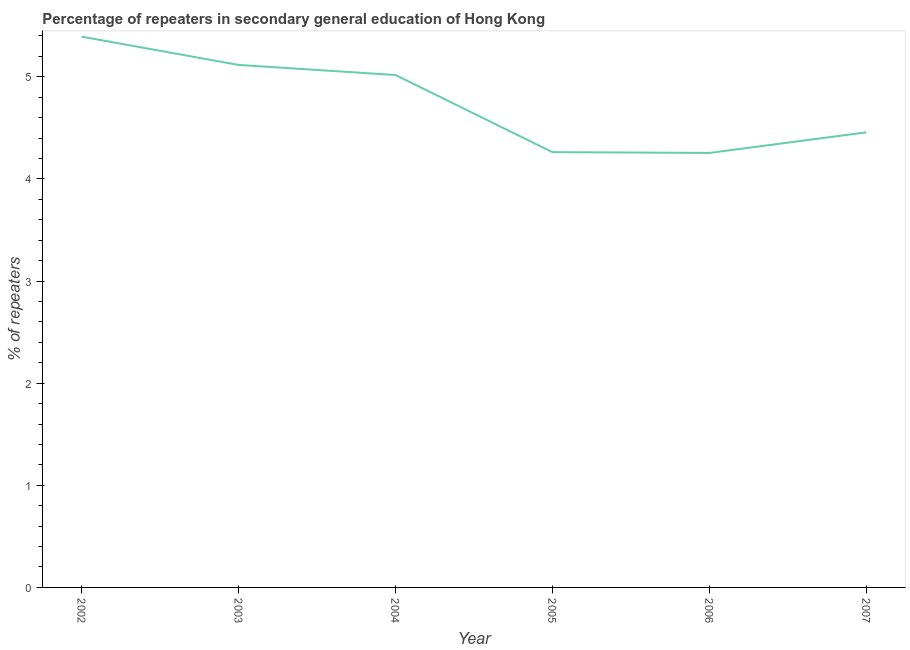What is the percentage of repeaters in 2007?
Provide a short and direct response. 4.46. Across all years, what is the maximum percentage of repeaters?
Your response must be concise. 5.39. Across all years, what is the minimum percentage of repeaters?
Give a very brief answer. 4.25. In which year was the percentage of repeaters maximum?
Your response must be concise. 2002. In which year was the percentage of repeaters minimum?
Offer a terse response. 2006. What is the sum of the percentage of repeaters?
Your response must be concise. 28.5. What is the difference between the percentage of repeaters in 2003 and 2004?
Ensure brevity in your answer.  0.1. What is the average percentage of repeaters per year?
Offer a very short reply. 4.75. What is the median percentage of repeaters?
Provide a succinct answer. 4.74. In how many years, is the percentage of repeaters greater than 2.2 %?
Make the answer very short. 6. What is the ratio of the percentage of repeaters in 2003 to that in 2007?
Make the answer very short. 1.15. What is the difference between the highest and the second highest percentage of repeaters?
Make the answer very short. 0.28. What is the difference between the highest and the lowest percentage of repeaters?
Keep it short and to the point. 1.14. How many lines are there?
Offer a very short reply. 1. Are the values on the major ticks of Y-axis written in scientific E-notation?
Your answer should be very brief. No. Does the graph contain any zero values?
Offer a very short reply. No. What is the title of the graph?
Provide a succinct answer. Percentage of repeaters in secondary general education of Hong Kong. What is the label or title of the Y-axis?
Keep it short and to the point. % of repeaters. What is the % of repeaters of 2002?
Offer a terse response. 5.39. What is the % of repeaters in 2003?
Offer a terse response. 5.12. What is the % of repeaters in 2004?
Ensure brevity in your answer.  5.02. What is the % of repeaters in 2005?
Make the answer very short. 4.26. What is the % of repeaters of 2006?
Provide a succinct answer. 4.25. What is the % of repeaters in 2007?
Your response must be concise. 4.46. What is the difference between the % of repeaters in 2002 and 2003?
Keep it short and to the point. 0.28. What is the difference between the % of repeaters in 2002 and 2004?
Your response must be concise. 0.38. What is the difference between the % of repeaters in 2002 and 2005?
Provide a succinct answer. 1.13. What is the difference between the % of repeaters in 2002 and 2006?
Offer a very short reply. 1.14. What is the difference between the % of repeaters in 2002 and 2007?
Provide a short and direct response. 0.94. What is the difference between the % of repeaters in 2003 and 2004?
Give a very brief answer. 0.1. What is the difference between the % of repeaters in 2003 and 2005?
Provide a short and direct response. 0.85. What is the difference between the % of repeaters in 2003 and 2006?
Provide a short and direct response. 0.86. What is the difference between the % of repeaters in 2003 and 2007?
Keep it short and to the point. 0.66. What is the difference between the % of repeaters in 2004 and 2005?
Offer a terse response. 0.76. What is the difference between the % of repeaters in 2004 and 2006?
Give a very brief answer. 0.76. What is the difference between the % of repeaters in 2004 and 2007?
Your answer should be compact. 0.56. What is the difference between the % of repeaters in 2005 and 2006?
Offer a very short reply. 0.01. What is the difference between the % of repeaters in 2005 and 2007?
Offer a terse response. -0.19. What is the difference between the % of repeaters in 2006 and 2007?
Your answer should be compact. -0.2. What is the ratio of the % of repeaters in 2002 to that in 2003?
Ensure brevity in your answer.  1.05. What is the ratio of the % of repeaters in 2002 to that in 2004?
Your response must be concise. 1.07. What is the ratio of the % of repeaters in 2002 to that in 2005?
Provide a succinct answer. 1.26. What is the ratio of the % of repeaters in 2002 to that in 2006?
Keep it short and to the point. 1.27. What is the ratio of the % of repeaters in 2002 to that in 2007?
Your response must be concise. 1.21. What is the ratio of the % of repeaters in 2003 to that in 2004?
Provide a short and direct response. 1.02. What is the ratio of the % of repeaters in 2003 to that in 2006?
Keep it short and to the point. 1.2. What is the ratio of the % of repeaters in 2003 to that in 2007?
Provide a short and direct response. 1.15. What is the ratio of the % of repeaters in 2004 to that in 2005?
Make the answer very short. 1.18. What is the ratio of the % of repeaters in 2004 to that in 2006?
Offer a terse response. 1.18. What is the ratio of the % of repeaters in 2004 to that in 2007?
Your response must be concise. 1.13. What is the ratio of the % of repeaters in 2005 to that in 2007?
Give a very brief answer. 0.96. What is the ratio of the % of repeaters in 2006 to that in 2007?
Make the answer very short. 0.95. 